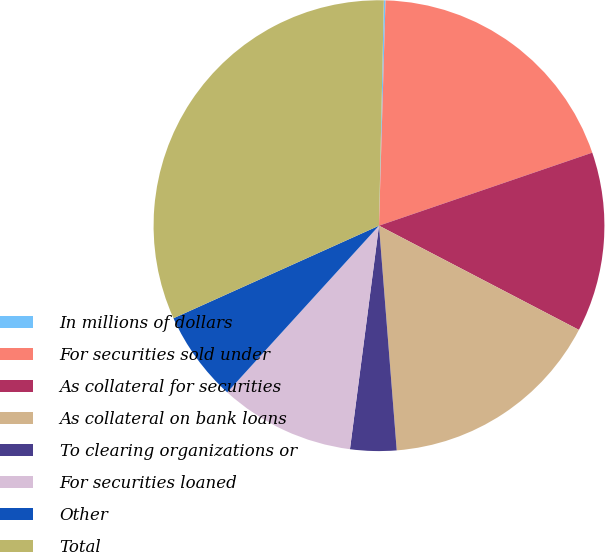<chart> <loc_0><loc_0><loc_500><loc_500><pie_chart><fcel>In millions of dollars<fcel>For securities sold under<fcel>As collateral for securities<fcel>As collateral on bank loans<fcel>To clearing organizations or<fcel>For securities loaned<fcel>Other<fcel>Total<nl><fcel>0.12%<fcel>19.29%<fcel>12.9%<fcel>16.1%<fcel>3.31%<fcel>9.7%<fcel>6.51%<fcel>32.08%<nl></chart> 